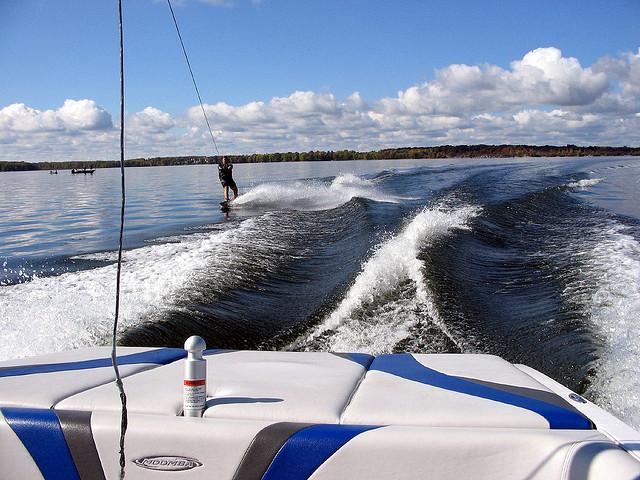Is the boat and skier alone on the water?
Quick response, please. No. Is the man water skiing?
Be succinct. Yes. Is there a wake behind the boat?
Keep it brief. Yes. 